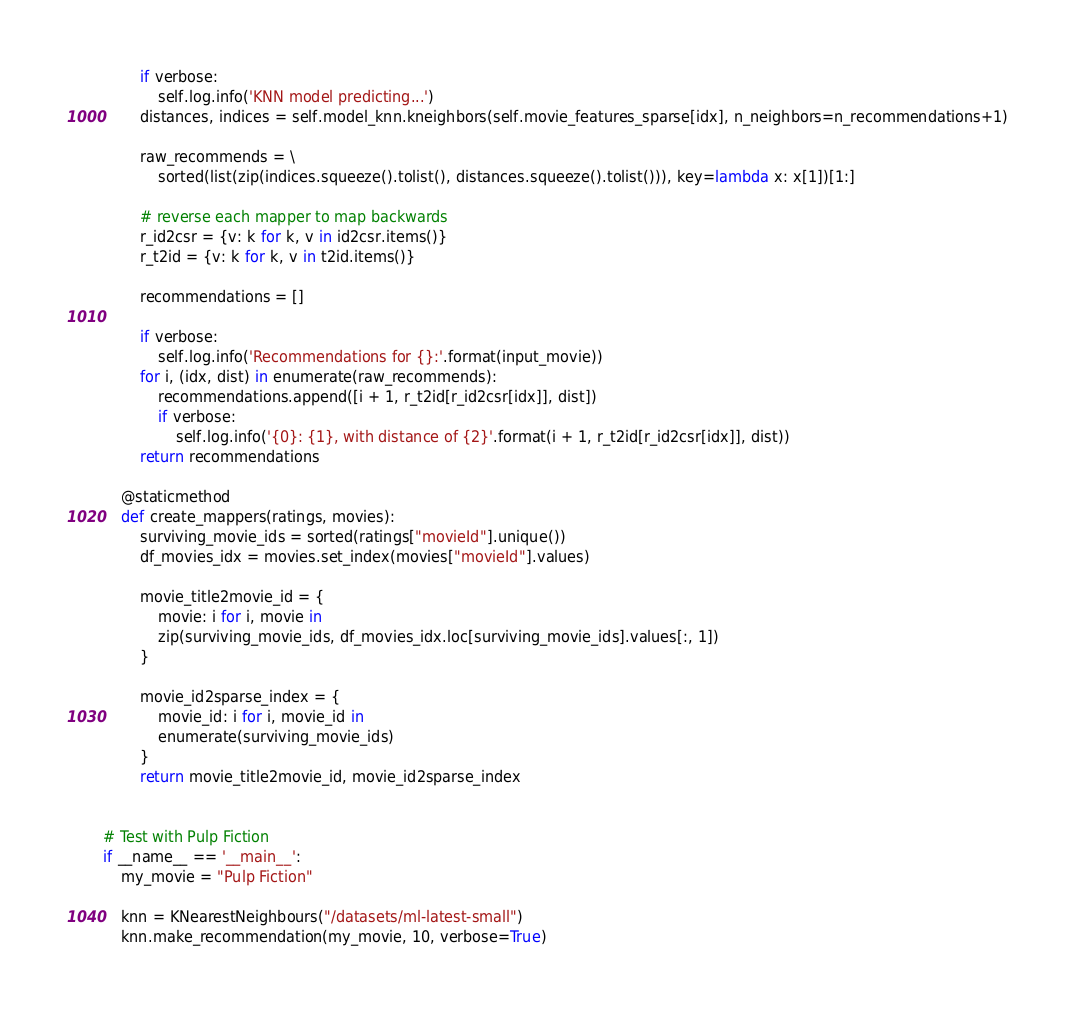<code> <loc_0><loc_0><loc_500><loc_500><_Python_>
        if verbose:
            self.log.info('KNN model predicting...')
        distances, indices = self.model_knn.kneighbors(self.movie_features_sparse[idx], n_neighbors=n_recommendations+1)

        raw_recommends = \
            sorted(list(zip(indices.squeeze().tolist(), distances.squeeze().tolist())), key=lambda x: x[1])[1:]

        # reverse each mapper to map backwards
        r_id2csr = {v: k for k, v in id2csr.items()}
        r_t2id = {v: k for k, v in t2id.items()}

        recommendations = []

        if verbose:
            self.log.info('Recommendations for {}:'.format(input_movie))
        for i, (idx, dist) in enumerate(raw_recommends):
            recommendations.append([i + 1, r_t2id[r_id2csr[idx]], dist])
            if verbose:
                self.log.info('{0}: {1}, with distance of {2}'.format(i + 1, r_t2id[r_id2csr[idx]], dist))
        return recommendations

    @staticmethod
    def create_mappers(ratings, movies):
        surviving_movie_ids = sorted(ratings["movieId"].unique())
        df_movies_idx = movies.set_index(movies["movieId"].values)

        movie_title2movie_id = {
            movie: i for i, movie in
            zip(surviving_movie_ids, df_movies_idx.loc[surviving_movie_ids].values[:, 1])
        }

        movie_id2sparse_index = {
            movie_id: i for i, movie_id in
            enumerate(surviving_movie_ids)
        }
        return movie_title2movie_id, movie_id2sparse_index


# Test with Pulp Fiction
if __name__ == '__main__':
    my_movie = "Pulp Fiction"

    knn = KNearestNeighbours("/datasets/ml-latest-small")
    knn.make_recommendation(my_movie, 10, verbose=True)
</code> 